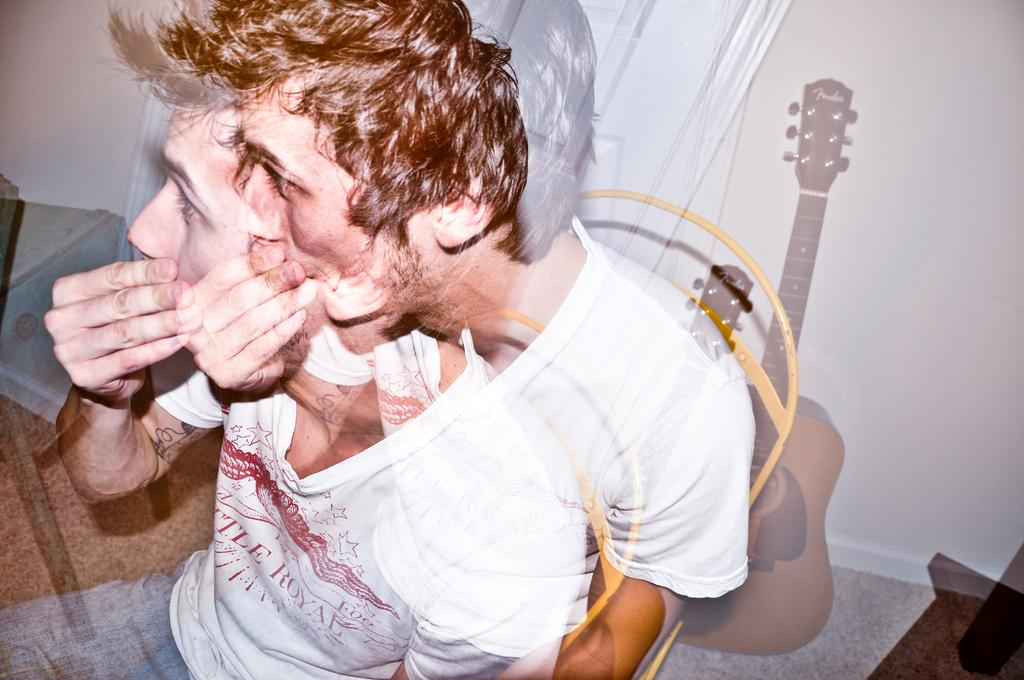What is the man in the image doing? The man is sitting on a chair in the image. What object can be seen on the right side of the image? There is a guitar on the right side of the image. What can be seen in the background of the image? There is a wall and a door in the background of the image. How much profit did the man make from playing the guitar in the image? There is no information about the man playing the guitar or making a profit in the image. 